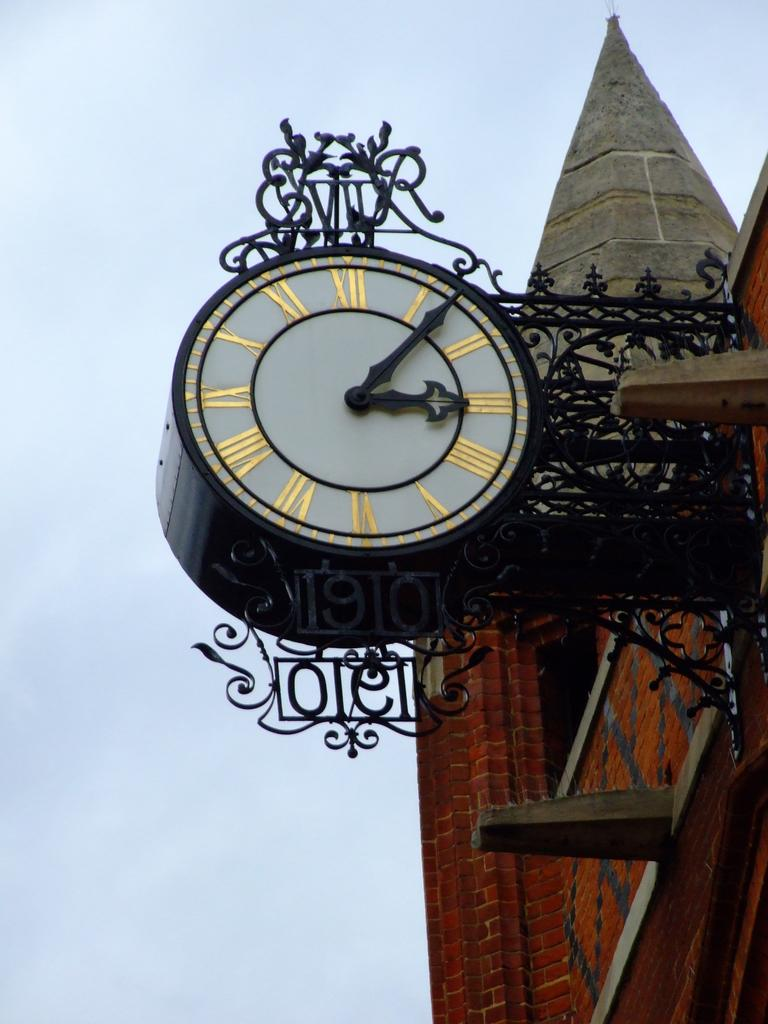What is the main subject of the image? The main subject of the image is a wall of a building. What is attached to the wall of the building? A clock is attached to the wall of the building. What can be seen behind the clock in the image? The sky is visible behind the clock. Where is the map of the city located in the image? There is no map of the city present in the image. What type of soup is being served at the party in the image? There is no party or soup present in the image. 